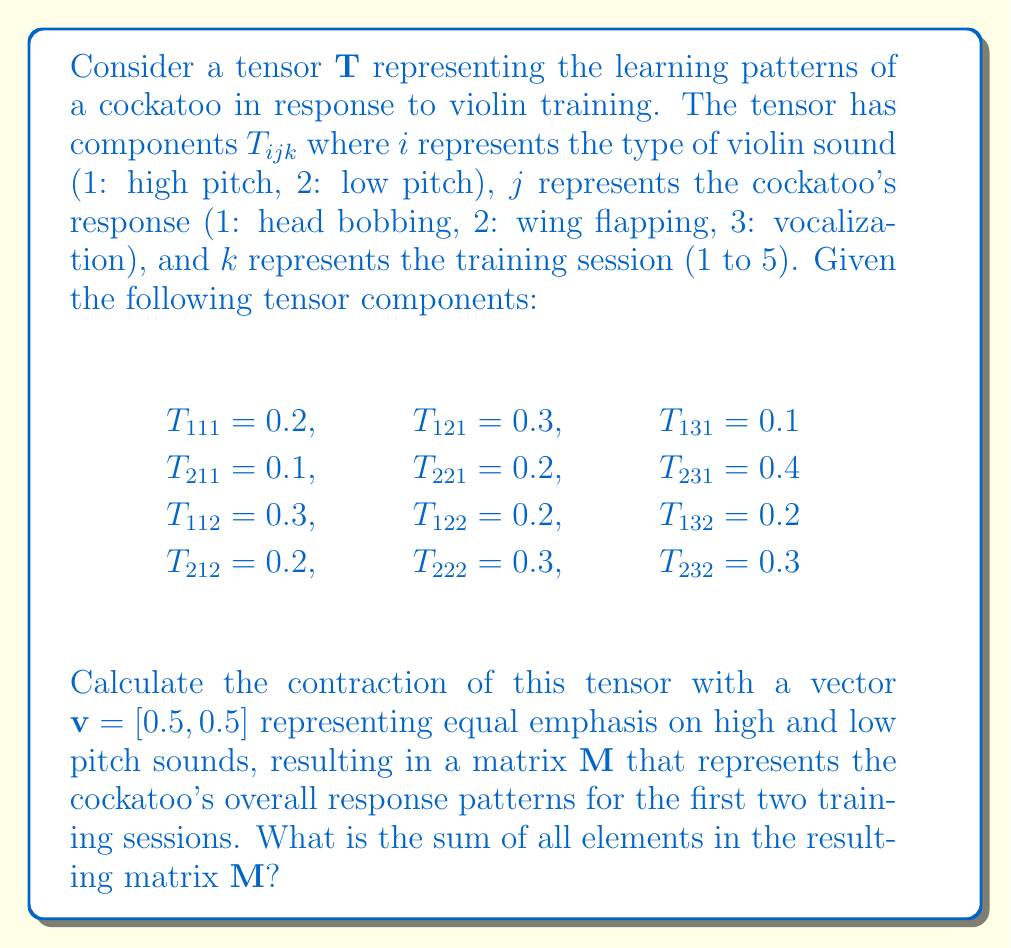Can you solve this math problem? To solve this problem, we need to follow these steps:

1) First, we need to understand what the contraction of the tensor $\mathbf{T}$ with the vector $\mathbf{v}$ means. This operation can be represented as:

   $$M_{jk} = \sum_{i=1}^2 T_{ijk} v_i$$

2) We need to calculate this for each combination of $j$ (1 to 3) and $k$ (1 to 2), as we're only considering the first two training sessions.

3) Let's calculate each element of the resulting matrix $\mathbf{M}$:

   $$M_{11} = T_{111}v_1 + T_{211}v_2 = 0.2 * 0.5 + 0.1 * 0.5 = 0.15$$
   $$M_{21} = T_{121}v_1 + T_{221}v_2 = 0.3 * 0.5 + 0.2 * 0.5 = 0.25$$
   $$M_{31} = T_{131}v_1 + T_{231}v_2 = 0.1 * 0.5 + 0.4 * 0.5 = 0.25$$
   $$M_{12} = T_{112}v_1 + T_{212}v_2 = 0.3 * 0.5 + 0.2 * 0.5 = 0.25$$
   $$M_{22} = T_{122}v_1 + T_{222}v_2 = 0.2 * 0.5 + 0.3 * 0.5 = 0.25$$
   $$M_{32} = T_{132}v_1 + T_{232}v_2 = 0.2 * 0.5 + 0.3 * 0.5 = 0.25$$

4) Now we have the matrix $\mathbf{M}$:

   $$\mathbf{M} = \begin{bmatrix}
   0.15 & 0.25 \\
   0.25 & 0.25 \\
   0.25 & 0.25
   \end{bmatrix}$$

5) To find the sum of all elements in $\mathbf{M}$, we add up all the values:

   $$0.15 + 0.25 + 0.25 + 0.25 + 0.25 + 0.25 = 1.4$$

Therefore, the sum of all elements in the resulting matrix $\mathbf{M}$ is 1.4.
Answer: 1.4 